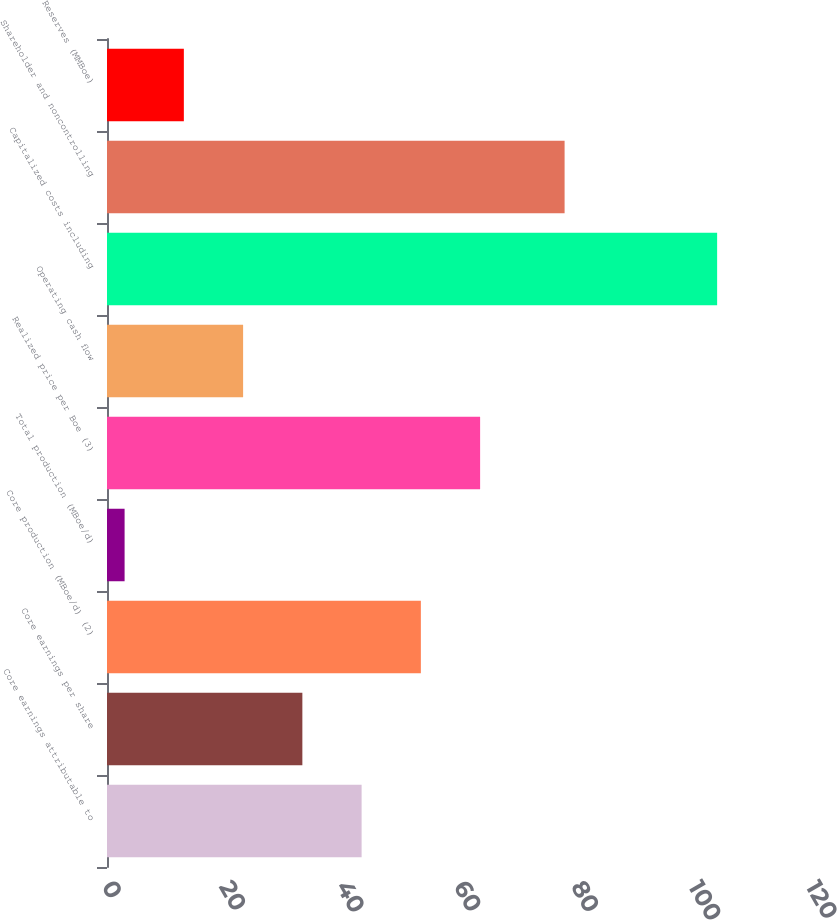Convert chart to OTSL. <chart><loc_0><loc_0><loc_500><loc_500><bar_chart><fcel>Core earnings attributable to<fcel>Core earnings per share<fcel>Core production (MBoe/d) (2)<fcel>Total production (MBoe/d)<fcel>Realized price per Boe (3)<fcel>Operating cash flow<fcel>Capitalized costs including<fcel>Shareholder and noncontrolling<fcel>Reserves (MMBoe)<nl><fcel>43.4<fcel>33.3<fcel>53.5<fcel>3<fcel>63.6<fcel>23.2<fcel>104<fcel>78<fcel>13.1<nl></chart> 